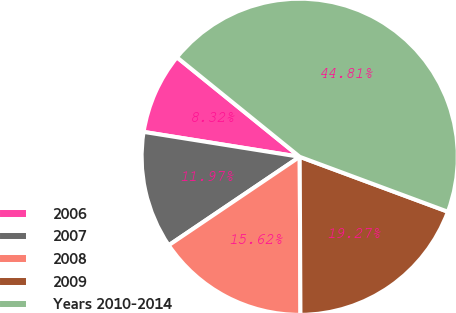Convert chart to OTSL. <chart><loc_0><loc_0><loc_500><loc_500><pie_chart><fcel>2006<fcel>2007<fcel>2008<fcel>2009<fcel>Years 2010-2014<nl><fcel>8.32%<fcel>11.97%<fcel>15.62%<fcel>19.27%<fcel>44.81%<nl></chart> 